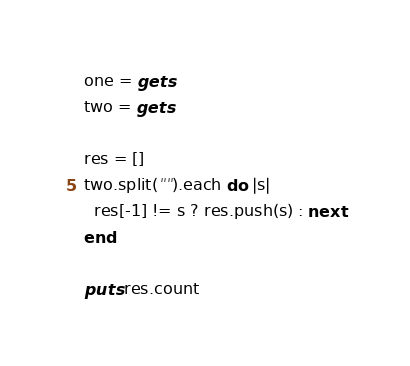<code> <loc_0><loc_0><loc_500><loc_500><_Ruby_>one = gets
two = gets
 
res = []
two.split("").each do |s|
  res[-1] != s ? res.push(s) : next
end
 
puts res.count</code> 